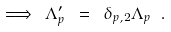<formula> <loc_0><loc_0><loc_500><loc_500>\Longrightarrow \ \Lambda _ { p } ^ { \prime } \ = \ \delta _ { p , 2 } \Lambda _ { p } \ .</formula> 